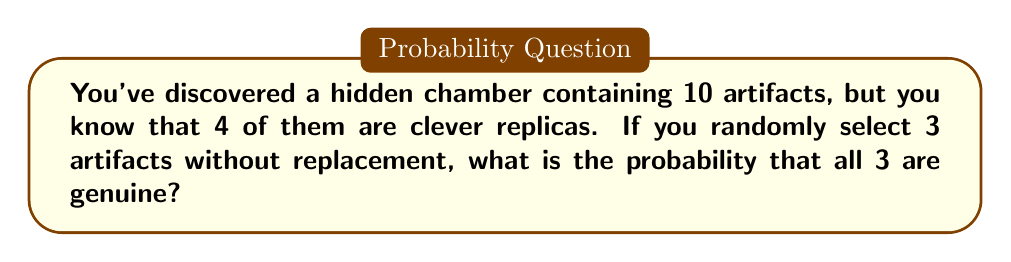Show me your answer to this math problem. Let's approach this step-by-step:

1) First, we need to calculate the total number of ways to select 3 artifacts out of 10. This is given by the combination formula:

   $$\binom{10}{3} = \frac{10!}{3!(10-3)!} = \frac{10!}{3!7!} = 120$$

2) Now, we need to calculate the number of ways to select 3 genuine artifacts out of the 6 genuine artifacts available. This is:

   $$\binom{6}{3} = \frac{6!}{3!(6-3)!} = \frac{6!}{3!3!} = 20$$

3) The probability is then the number of favorable outcomes divided by the total number of possible outcomes:

   $$P(\text{all 3 genuine}) = \frac{\text{ways to select 3 genuine}}{\text{total ways to select 3}}$$

   $$P(\text{all 3 genuine}) = \frac{\binom{6}{3}}{\binom{10}{3}} = \frac{20}{120} = \frac{1}{6}$$

Therefore, the probability of selecting 3 genuine artifacts is $\frac{1}{6}$ or approximately 0.1667.
Answer: $\frac{1}{6}$ 